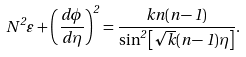Convert formula to latex. <formula><loc_0><loc_0><loc_500><loc_500>N ^ { 2 } \varepsilon + \left ( \frac { d \phi } { d \eta } \right ) ^ { 2 } = \frac { k n ( n - 1 ) } { \sin ^ { 2 } \left [ \sqrt { k } ( n - 1 ) \eta \right ] } .</formula> 